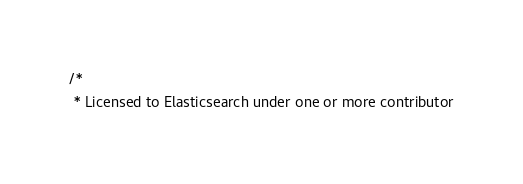Convert code to text. <code><loc_0><loc_0><loc_500><loc_500><_Java_>/*
 * Licensed to Elasticsearch under one or more contributor</code> 